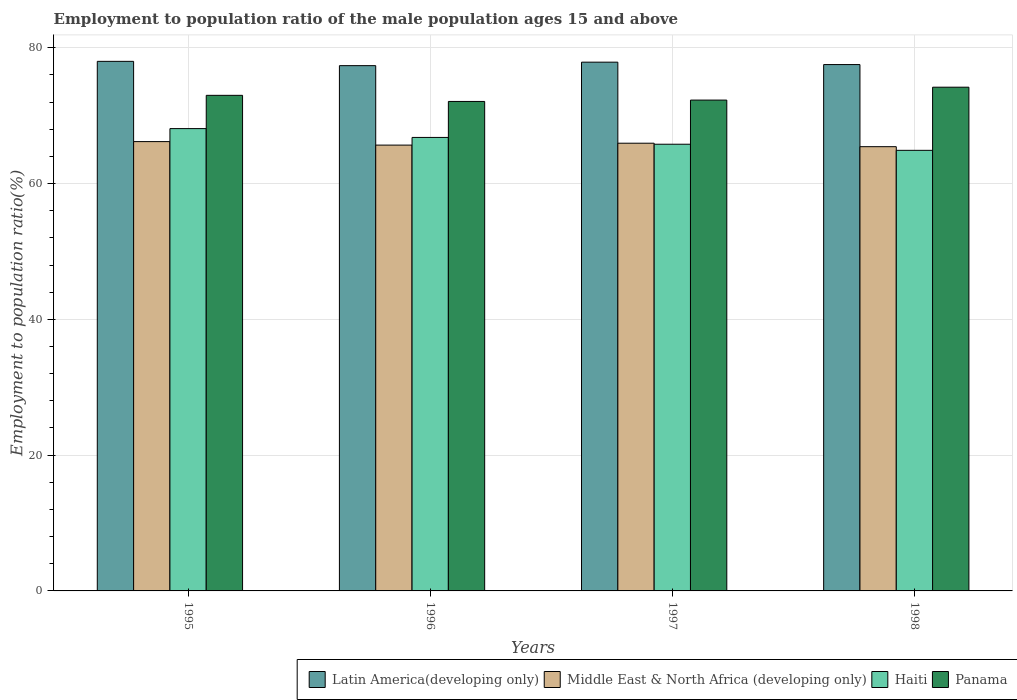Are the number of bars per tick equal to the number of legend labels?
Offer a terse response. Yes. What is the employment to population ratio in Latin America(developing only) in 1997?
Ensure brevity in your answer.  77.89. Across all years, what is the maximum employment to population ratio in Haiti?
Your answer should be very brief. 68.1. Across all years, what is the minimum employment to population ratio in Panama?
Ensure brevity in your answer.  72.1. In which year was the employment to population ratio in Panama minimum?
Make the answer very short. 1996. What is the total employment to population ratio in Middle East & North Africa (developing only) in the graph?
Provide a succinct answer. 263.24. What is the difference between the employment to population ratio in Latin America(developing only) in 1995 and that in 1996?
Give a very brief answer. 0.63. What is the difference between the employment to population ratio in Middle East & North Africa (developing only) in 1998 and the employment to population ratio in Latin America(developing only) in 1997?
Offer a terse response. -12.45. What is the average employment to population ratio in Panama per year?
Provide a succinct answer. 72.9. In the year 1995, what is the difference between the employment to population ratio in Haiti and employment to population ratio in Middle East & North Africa (developing only)?
Ensure brevity in your answer.  1.92. What is the ratio of the employment to population ratio in Panama in 1995 to that in 1997?
Offer a very short reply. 1.01. Is the difference between the employment to population ratio in Haiti in 1996 and 1997 greater than the difference between the employment to population ratio in Middle East & North Africa (developing only) in 1996 and 1997?
Offer a very short reply. Yes. What is the difference between the highest and the second highest employment to population ratio in Latin America(developing only)?
Your answer should be compact. 0.12. What is the difference between the highest and the lowest employment to population ratio in Middle East & North Africa (developing only)?
Provide a succinct answer. 0.75. Is the sum of the employment to population ratio in Latin America(developing only) in 1995 and 1997 greater than the maximum employment to population ratio in Haiti across all years?
Offer a very short reply. Yes. What does the 3rd bar from the left in 1996 represents?
Provide a succinct answer. Haiti. What does the 3rd bar from the right in 1995 represents?
Offer a terse response. Middle East & North Africa (developing only). How many bars are there?
Ensure brevity in your answer.  16. Does the graph contain any zero values?
Ensure brevity in your answer.  No. Where does the legend appear in the graph?
Keep it short and to the point. Bottom right. How many legend labels are there?
Your answer should be very brief. 4. How are the legend labels stacked?
Provide a short and direct response. Horizontal. What is the title of the graph?
Your answer should be compact. Employment to population ratio of the male population ages 15 and above. What is the label or title of the X-axis?
Your response must be concise. Years. What is the Employment to population ratio(%) in Latin America(developing only) in 1995?
Ensure brevity in your answer.  78.01. What is the Employment to population ratio(%) of Middle East & North Africa (developing only) in 1995?
Keep it short and to the point. 66.18. What is the Employment to population ratio(%) in Haiti in 1995?
Keep it short and to the point. 68.1. What is the Employment to population ratio(%) in Latin America(developing only) in 1996?
Your answer should be compact. 77.37. What is the Employment to population ratio(%) of Middle East & North Africa (developing only) in 1996?
Ensure brevity in your answer.  65.67. What is the Employment to population ratio(%) of Haiti in 1996?
Keep it short and to the point. 66.8. What is the Employment to population ratio(%) in Panama in 1996?
Offer a terse response. 72.1. What is the Employment to population ratio(%) in Latin America(developing only) in 1997?
Give a very brief answer. 77.89. What is the Employment to population ratio(%) in Middle East & North Africa (developing only) in 1997?
Ensure brevity in your answer.  65.95. What is the Employment to population ratio(%) in Haiti in 1997?
Offer a terse response. 65.8. What is the Employment to population ratio(%) of Panama in 1997?
Offer a very short reply. 72.3. What is the Employment to population ratio(%) in Latin America(developing only) in 1998?
Give a very brief answer. 77.53. What is the Employment to population ratio(%) of Middle East & North Africa (developing only) in 1998?
Your answer should be very brief. 65.44. What is the Employment to population ratio(%) in Haiti in 1998?
Your response must be concise. 64.9. What is the Employment to population ratio(%) in Panama in 1998?
Your response must be concise. 74.2. Across all years, what is the maximum Employment to population ratio(%) in Latin America(developing only)?
Offer a terse response. 78.01. Across all years, what is the maximum Employment to population ratio(%) of Middle East & North Africa (developing only)?
Ensure brevity in your answer.  66.18. Across all years, what is the maximum Employment to population ratio(%) in Haiti?
Provide a succinct answer. 68.1. Across all years, what is the maximum Employment to population ratio(%) in Panama?
Your answer should be very brief. 74.2. Across all years, what is the minimum Employment to population ratio(%) in Latin America(developing only)?
Keep it short and to the point. 77.37. Across all years, what is the minimum Employment to population ratio(%) in Middle East & North Africa (developing only)?
Give a very brief answer. 65.44. Across all years, what is the minimum Employment to population ratio(%) in Haiti?
Make the answer very short. 64.9. Across all years, what is the minimum Employment to population ratio(%) in Panama?
Offer a terse response. 72.1. What is the total Employment to population ratio(%) of Latin America(developing only) in the graph?
Ensure brevity in your answer.  310.8. What is the total Employment to population ratio(%) in Middle East & North Africa (developing only) in the graph?
Provide a short and direct response. 263.24. What is the total Employment to population ratio(%) of Haiti in the graph?
Offer a very short reply. 265.6. What is the total Employment to population ratio(%) of Panama in the graph?
Provide a succinct answer. 291.6. What is the difference between the Employment to population ratio(%) of Latin America(developing only) in 1995 and that in 1996?
Provide a succinct answer. 0.63. What is the difference between the Employment to population ratio(%) of Middle East & North Africa (developing only) in 1995 and that in 1996?
Ensure brevity in your answer.  0.51. What is the difference between the Employment to population ratio(%) in Panama in 1995 and that in 1996?
Give a very brief answer. 0.9. What is the difference between the Employment to population ratio(%) in Latin America(developing only) in 1995 and that in 1997?
Provide a short and direct response. 0.12. What is the difference between the Employment to population ratio(%) in Middle East & North Africa (developing only) in 1995 and that in 1997?
Provide a short and direct response. 0.24. What is the difference between the Employment to population ratio(%) of Haiti in 1995 and that in 1997?
Offer a very short reply. 2.3. What is the difference between the Employment to population ratio(%) of Latin America(developing only) in 1995 and that in 1998?
Ensure brevity in your answer.  0.47. What is the difference between the Employment to population ratio(%) of Middle East & North Africa (developing only) in 1995 and that in 1998?
Give a very brief answer. 0.75. What is the difference between the Employment to population ratio(%) in Latin America(developing only) in 1996 and that in 1997?
Make the answer very short. -0.51. What is the difference between the Employment to population ratio(%) of Middle East & North Africa (developing only) in 1996 and that in 1997?
Your answer should be compact. -0.28. What is the difference between the Employment to population ratio(%) of Panama in 1996 and that in 1997?
Keep it short and to the point. -0.2. What is the difference between the Employment to population ratio(%) of Latin America(developing only) in 1996 and that in 1998?
Give a very brief answer. -0.16. What is the difference between the Employment to population ratio(%) in Middle East & North Africa (developing only) in 1996 and that in 1998?
Your answer should be compact. 0.23. What is the difference between the Employment to population ratio(%) of Panama in 1996 and that in 1998?
Give a very brief answer. -2.1. What is the difference between the Employment to population ratio(%) in Latin America(developing only) in 1997 and that in 1998?
Provide a short and direct response. 0.36. What is the difference between the Employment to population ratio(%) of Middle East & North Africa (developing only) in 1997 and that in 1998?
Your response must be concise. 0.51. What is the difference between the Employment to population ratio(%) in Panama in 1997 and that in 1998?
Keep it short and to the point. -1.9. What is the difference between the Employment to population ratio(%) of Latin America(developing only) in 1995 and the Employment to population ratio(%) of Middle East & North Africa (developing only) in 1996?
Offer a very short reply. 12.34. What is the difference between the Employment to population ratio(%) in Latin America(developing only) in 1995 and the Employment to population ratio(%) in Haiti in 1996?
Offer a very short reply. 11.21. What is the difference between the Employment to population ratio(%) in Latin America(developing only) in 1995 and the Employment to population ratio(%) in Panama in 1996?
Ensure brevity in your answer.  5.91. What is the difference between the Employment to population ratio(%) in Middle East & North Africa (developing only) in 1995 and the Employment to population ratio(%) in Haiti in 1996?
Provide a short and direct response. -0.62. What is the difference between the Employment to population ratio(%) of Middle East & North Africa (developing only) in 1995 and the Employment to population ratio(%) of Panama in 1996?
Your answer should be compact. -5.92. What is the difference between the Employment to population ratio(%) in Haiti in 1995 and the Employment to population ratio(%) in Panama in 1996?
Your response must be concise. -4. What is the difference between the Employment to population ratio(%) of Latin America(developing only) in 1995 and the Employment to population ratio(%) of Middle East & North Africa (developing only) in 1997?
Give a very brief answer. 12.06. What is the difference between the Employment to population ratio(%) of Latin America(developing only) in 1995 and the Employment to population ratio(%) of Haiti in 1997?
Provide a short and direct response. 12.21. What is the difference between the Employment to population ratio(%) in Latin America(developing only) in 1995 and the Employment to population ratio(%) in Panama in 1997?
Make the answer very short. 5.71. What is the difference between the Employment to population ratio(%) in Middle East & North Africa (developing only) in 1995 and the Employment to population ratio(%) in Haiti in 1997?
Make the answer very short. 0.38. What is the difference between the Employment to population ratio(%) in Middle East & North Africa (developing only) in 1995 and the Employment to population ratio(%) in Panama in 1997?
Offer a very short reply. -6.12. What is the difference between the Employment to population ratio(%) of Haiti in 1995 and the Employment to population ratio(%) of Panama in 1997?
Give a very brief answer. -4.2. What is the difference between the Employment to population ratio(%) in Latin America(developing only) in 1995 and the Employment to population ratio(%) in Middle East & North Africa (developing only) in 1998?
Provide a succinct answer. 12.57. What is the difference between the Employment to population ratio(%) in Latin America(developing only) in 1995 and the Employment to population ratio(%) in Haiti in 1998?
Provide a succinct answer. 13.11. What is the difference between the Employment to population ratio(%) in Latin America(developing only) in 1995 and the Employment to population ratio(%) in Panama in 1998?
Make the answer very short. 3.81. What is the difference between the Employment to population ratio(%) of Middle East & North Africa (developing only) in 1995 and the Employment to population ratio(%) of Haiti in 1998?
Your response must be concise. 1.28. What is the difference between the Employment to population ratio(%) of Middle East & North Africa (developing only) in 1995 and the Employment to population ratio(%) of Panama in 1998?
Ensure brevity in your answer.  -8.02. What is the difference between the Employment to population ratio(%) in Haiti in 1995 and the Employment to population ratio(%) in Panama in 1998?
Your answer should be very brief. -6.1. What is the difference between the Employment to population ratio(%) of Latin America(developing only) in 1996 and the Employment to population ratio(%) of Middle East & North Africa (developing only) in 1997?
Provide a short and direct response. 11.42. What is the difference between the Employment to population ratio(%) of Latin America(developing only) in 1996 and the Employment to population ratio(%) of Haiti in 1997?
Keep it short and to the point. 11.57. What is the difference between the Employment to population ratio(%) of Latin America(developing only) in 1996 and the Employment to population ratio(%) of Panama in 1997?
Your answer should be very brief. 5.07. What is the difference between the Employment to population ratio(%) of Middle East & North Africa (developing only) in 1996 and the Employment to population ratio(%) of Haiti in 1997?
Give a very brief answer. -0.13. What is the difference between the Employment to population ratio(%) in Middle East & North Africa (developing only) in 1996 and the Employment to population ratio(%) in Panama in 1997?
Your answer should be very brief. -6.63. What is the difference between the Employment to population ratio(%) in Haiti in 1996 and the Employment to population ratio(%) in Panama in 1997?
Offer a terse response. -5.5. What is the difference between the Employment to population ratio(%) of Latin America(developing only) in 1996 and the Employment to population ratio(%) of Middle East & North Africa (developing only) in 1998?
Give a very brief answer. 11.94. What is the difference between the Employment to population ratio(%) in Latin America(developing only) in 1996 and the Employment to population ratio(%) in Haiti in 1998?
Make the answer very short. 12.47. What is the difference between the Employment to population ratio(%) in Latin America(developing only) in 1996 and the Employment to population ratio(%) in Panama in 1998?
Your response must be concise. 3.17. What is the difference between the Employment to population ratio(%) of Middle East & North Africa (developing only) in 1996 and the Employment to population ratio(%) of Haiti in 1998?
Your answer should be very brief. 0.77. What is the difference between the Employment to population ratio(%) in Middle East & North Africa (developing only) in 1996 and the Employment to population ratio(%) in Panama in 1998?
Your response must be concise. -8.53. What is the difference between the Employment to population ratio(%) in Latin America(developing only) in 1997 and the Employment to population ratio(%) in Middle East & North Africa (developing only) in 1998?
Your answer should be very brief. 12.45. What is the difference between the Employment to population ratio(%) in Latin America(developing only) in 1997 and the Employment to population ratio(%) in Haiti in 1998?
Keep it short and to the point. 12.99. What is the difference between the Employment to population ratio(%) of Latin America(developing only) in 1997 and the Employment to population ratio(%) of Panama in 1998?
Provide a succinct answer. 3.69. What is the difference between the Employment to population ratio(%) in Middle East & North Africa (developing only) in 1997 and the Employment to population ratio(%) in Haiti in 1998?
Your answer should be compact. 1.05. What is the difference between the Employment to population ratio(%) of Middle East & North Africa (developing only) in 1997 and the Employment to population ratio(%) of Panama in 1998?
Ensure brevity in your answer.  -8.25. What is the difference between the Employment to population ratio(%) in Haiti in 1997 and the Employment to population ratio(%) in Panama in 1998?
Keep it short and to the point. -8.4. What is the average Employment to population ratio(%) of Latin America(developing only) per year?
Ensure brevity in your answer.  77.7. What is the average Employment to population ratio(%) in Middle East & North Africa (developing only) per year?
Give a very brief answer. 65.81. What is the average Employment to population ratio(%) of Haiti per year?
Offer a very short reply. 66.4. What is the average Employment to population ratio(%) of Panama per year?
Provide a succinct answer. 72.9. In the year 1995, what is the difference between the Employment to population ratio(%) in Latin America(developing only) and Employment to population ratio(%) in Middle East & North Africa (developing only)?
Your response must be concise. 11.82. In the year 1995, what is the difference between the Employment to population ratio(%) of Latin America(developing only) and Employment to population ratio(%) of Haiti?
Keep it short and to the point. 9.91. In the year 1995, what is the difference between the Employment to population ratio(%) of Latin America(developing only) and Employment to population ratio(%) of Panama?
Give a very brief answer. 5.01. In the year 1995, what is the difference between the Employment to population ratio(%) in Middle East & North Africa (developing only) and Employment to population ratio(%) in Haiti?
Offer a very short reply. -1.92. In the year 1995, what is the difference between the Employment to population ratio(%) of Middle East & North Africa (developing only) and Employment to population ratio(%) of Panama?
Keep it short and to the point. -6.82. In the year 1996, what is the difference between the Employment to population ratio(%) of Latin America(developing only) and Employment to population ratio(%) of Middle East & North Africa (developing only)?
Provide a short and direct response. 11.7. In the year 1996, what is the difference between the Employment to population ratio(%) in Latin America(developing only) and Employment to population ratio(%) in Haiti?
Offer a terse response. 10.57. In the year 1996, what is the difference between the Employment to population ratio(%) in Latin America(developing only) and Employment to population ratio(%) in Panama?
Make the answer very short. 5.27. In the year 1996, what is the difference between the Employment to population ratio(%) in Middle East & North Africa (developing only) and Employment to population ratio(%) in Haiti?
Keep it short and to the point. -1.13. In the year 1996, what is the difference between the Employment to population ratio(%) of Middle East & North Africa (developing only) and Employment to population ratio(%) of Panama?
Offer a very short reply. -6.43. In the year 1996, what is the difference between the Employment to population ratio(%) of Haiti and Employment to population ratio(%) of Panama?
Provide a succinct answer. -5.3. In the year 1997, what is the difference between the Employment to population ratio(%) of Latin America(developing only) and Employment to population ratio(%) of Middle East & North Africa (developing only)?
Offer a terse response. 11.94. In the year 1997, what is the difference between the Employment to population ratio(%) of Latin America(developing only) and Employment to population ratio(%) of Haiti?
Ensure brevity in your answer.  12.09. In the year 1997, what is the difference between the Employment to population ratio(%) in Latin America(developing only) and Employment to population ratio(%) in Panama?
Your answer should be very brief. 5.59. In the year 1997, what is the difference between the Employment to population ratio(%) in Middle East & North Africa (developing only) and Employment to population ratio(%) in Haiti?
Ensure brevity in your answer.  0.15. In the year 1997, what is the difference between the Employment to population ratio(%) of Middle East & North Africa (developing only) and Employment to population ratio(%) of Panama?
Your response must be concise. -6.35. In the year 1997, what is the difference between the Employment to population ratio(%) in Haiti and Employment to population ratio(%) in Panama?
Ensure brevity in your answer.  -6.5. In the year 1998, what is the difference between the Employment to population ratio(%) of Latin America(developing only) and Employment to population ratio(%) of Middle East & North Africa (developing only)?
Give a very brief answer. 12.09. In the year 1998, what is the difference between the Employment to population ratio(%) in Latin America(developing only) and Employment to population ratio(%) in Haiti?
Offer a terse response. 12.63. In the year 1998, what is the difference between the Employment to population ratio(%) in Latin America(developing only) and Employment to population ratio(%) in Panama?
Your response must be concise. 3.33. In the year 1998, what is the difference between the Employment to population ratio(%) in Middle East & North Africa (developing only) and Employment to population ratio(%) in Haiti?
Provide a short and direct response. 0.54. In the year 1998, what is the difference between the Employment to population ratio(%) of Middle East & North Africa (developing only) and Employment to population ratio(%) of Panama?
Make the answer very short. -8.76. What is the ratio of the Employment to population ratio(%) of Latin America(developing only) in 1995 to that in 1996?
Make the answer very short. 1.01. What is the ratio of the Employment to population ratio(%) in Haiti in 1995 to that in 1996?
Make the answer very short. 1.02. What is the ratio of the Employment to population ratio(%) in Panama in 1995 to that in 1996?
Keep it short and to the point. 1.01. What is the ratio of the Employment to population ratio(%) in Middle East & North Africa (developing only) in 1995 to that in 1997?
Your answer should be compact. 1. What is the ratio of the Employment to population ratio(%) in Haiti in 1995 to that in 1997?
Your response must be concise. 1.03. What is the ratio of the Employment to population ratio(%) in Panama in 1995 to that in 1997?
Offer a terse response. 1.01. What is the ratio of the Employment to population ratio(%) of Latin America(developing only) in 1995 to that in 1998?
Your answer should be compact. 1.01. What is the ratio of the Employment to population ratio(%) in Middle East & North Africa (developing only) in 1995 to that in 1998?
Provide a succinct answer. 1.01. What is the ratio of the Employment to population ratio(%) in Haiti in 1995 to that in 1998?
Give a very brief answer. 1.05. What is the ratio of the Employment to population ratio(%) in Panama in 1995 to that in 1998?
Your answer should be compact. 0.98. What is the ratio of the Employment to population ratio(%) in Latin America(developing only) in 1996 to that in 1997?
Your response must be concise. 0.99. What is the ratio of the Employment to population ratio(%) of Middle East & North Africa (developing only) in 1996 to that in 1997?
Offer a very short reply. 1. What is the ratio of the Employment to population ratio(%) of Haiti in 1996 to that in 1997?
Provide a succinct answer. 1.02. What is the ratio of the Employment to population ratio(%) in Panama in 1996 to that in 1997?
Provide a short and direct response. 1. What is the ratio of the Employment to population ratio(%) of Haiti in 1996 to that in 1998?
Provide a short and direct response. 1.03. What is the ratio of the Employment to population ratio(%) of Panama in 1996 to that in 1998?
Provide a short and direct response. 0.97. What is the ratio of the Employment to population ratio(%) of Latin America(developing only) in 1997 to that in 1998?
Offer a terse response. 1. What is the ratio of the Employment to population ratio(%) of Middle East & North Africa (developing only) in 1997 to that in 1998?
Make the answer very short. 1.01. What is the ratio of the Employment to population ratio(%) in Haiti in 1997 to that in 1998?
Make the answer very short. 1.01. What is the ratio of the Employment to population ratio(%) of Panama in 1997 to that in 1998?
Offer a terse response. 0.97. What is the difference between the highest and the second highest Employment to population ratio(%) in Latin America(developing only)?
Ensure brevity in your answer.  0.12. What is the difference between the highest and the second highest Employment to population ratio(%) of Middle East & North Africa (developing only)?
Your response must be concise. 0.24. What is the difference between the highest and the second highest Employment to population ratio(%) in Haiti?
Offer a terse response. 1.3. What is the difference between the highest and the second highest Employment to population ratio(%) in Panama?
Your response must be concise. 1.2. What is the difference between the highest and the lowest Employment to population ratio(%) in Latin America(developing only)?
Ensure brevity in your answer.  0.63. What is the difference between the highest and the lowest Employment to population ratio(%) in Middle East & North Africa (developing only)?
Provide a succinct answer. 0.75. What is the difference between the highest and the lowest Employment to population ratio(%) of Haiti?
Provide a succinct answer. 3.2. 